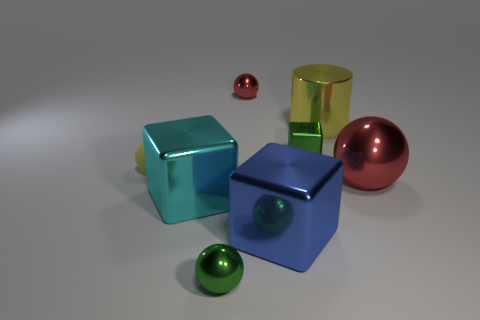Subtract 1 blocks. How many blocks are left? 2 Subtract all green spheres. How many spheres are left? 3 Subtract all small green shiny spheres. How many spheres are left? 3 Subtract all gray spheres. Subtract all brown cubes. How many spheres are left? 4 Add 2 small gray rubber cylinders. How many objects exist? 10 Subtract all blocks. How many objects are left? 5 Add 5 cubes. How many cubes are left? 8 Add 2 cyan rubber cylinders. How many cyan rubber cylinders exist? 2 Subtract 0 purple balls. How many objects are left? 8 Subtract all cyan objects. Subtract all small red balls. How many objects are left? 6 